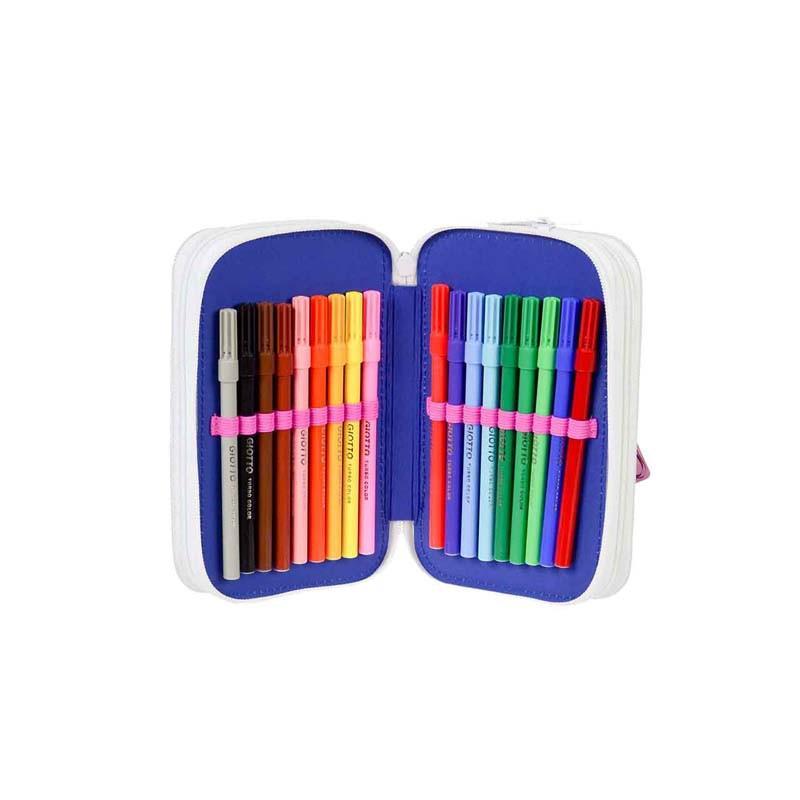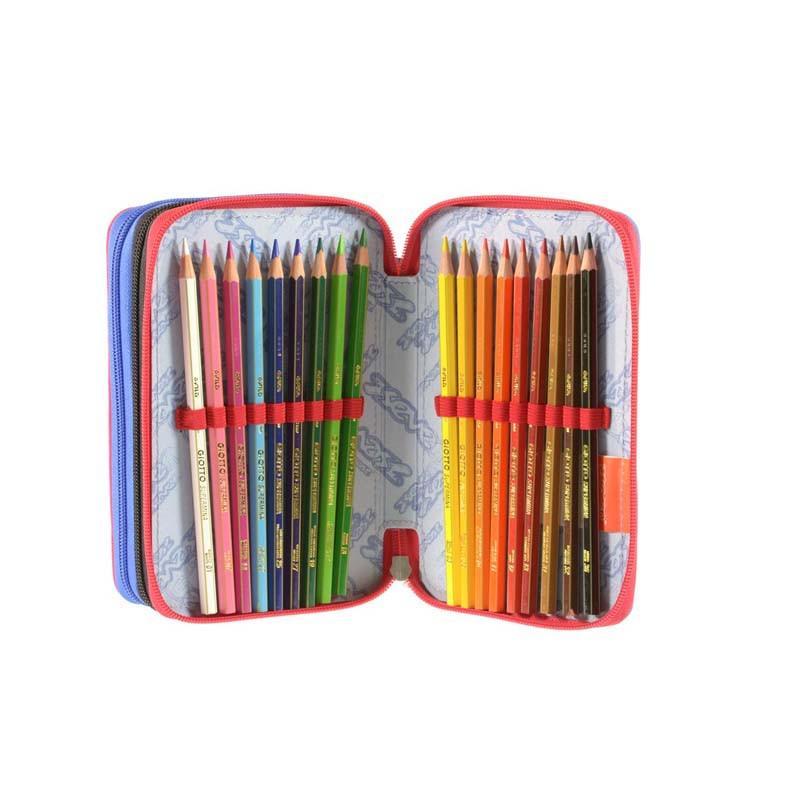The first image is the image on the left, the second image is the image on the right. For the images shown, is this caption "Each image shows one penicl case that opens flat, and all pencil cases contain only writing implements." true? Answer yes or no. Yes. The first image is the image on the left, the second image is the image on the right. Examine the images to the left and right. Is the description "At least one of the pencil cases has a pencil sharpener fastened within." accurate? Answer yes or no. No. 